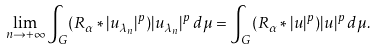<formula> <loc_0><loc_0><loc_500><loc_500>\underset { n \rightarrow + \infty } { \lim } \int _ { G } ( R _ { \alpha } \ast | u _ { \lambda _ { n } } | ^ { p } ) | u _ { \lambda _ { n } } | ^ { p } \, d \mu = \int _ { G } ( R _ { \alpha } \ast | u | ^ { p } ) | u | ^ { p } \, d \mu .</formula> 